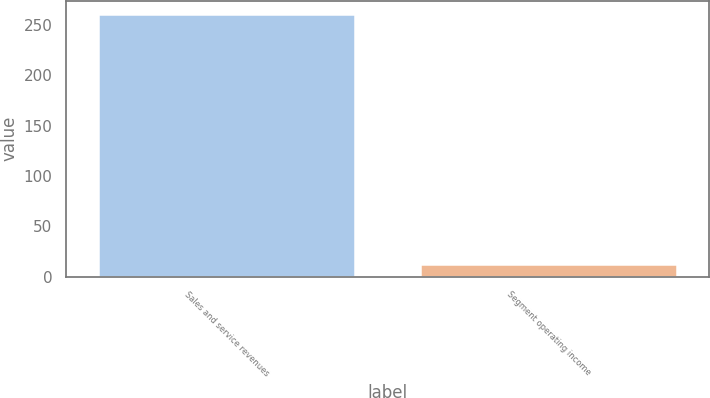<chart> <loc_0><loc_0><loc_500><loc_500><bar_chart><fcel>Sales and service revenues<fcel>Segment operating income<nl><fcel>261<fcel>13<nl></chart> 